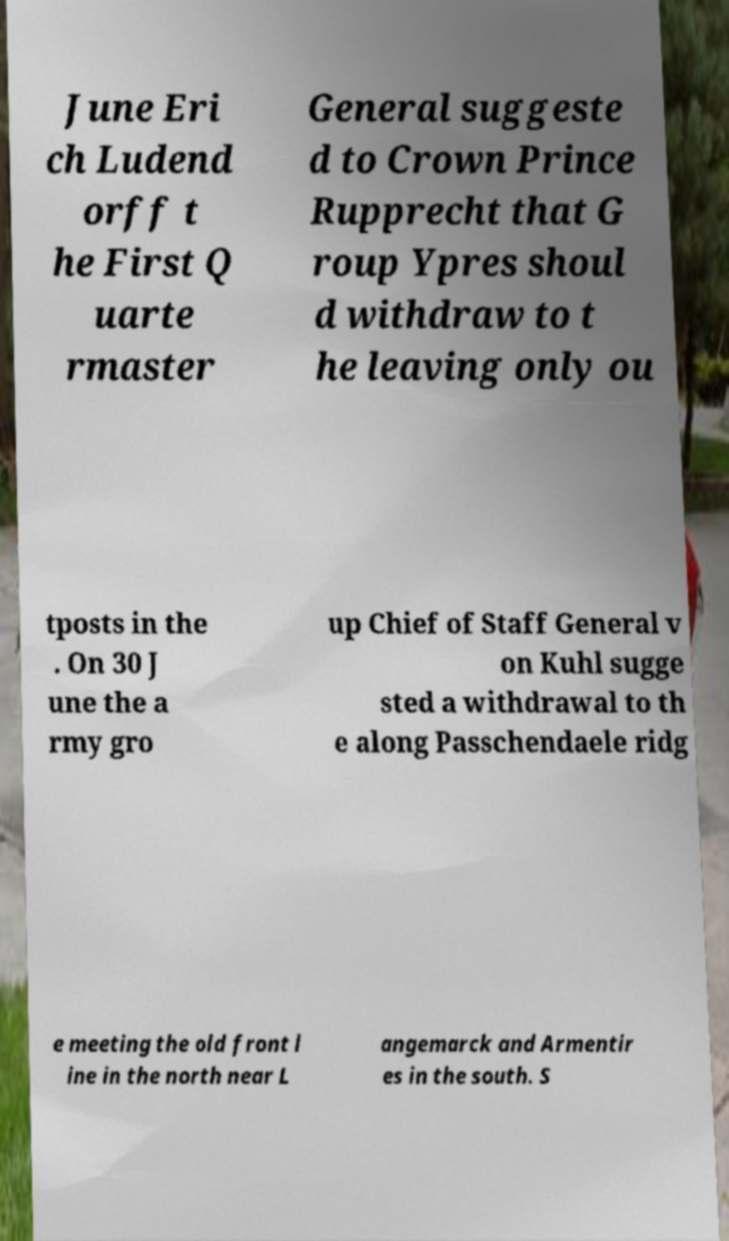Please identify and transcribe the text found in this image. June Eri ch Ludend orff t he First Q uarte rmaster General suggeste d to Crown Prince Rupprecht that G roup Ypres shoul d withdraw to t he leaving only ou tposts in the . On 30 J une the a rmy gro up Chief of Staff General v on Kuhl sugge sted a withdrawal to th e along Passchendaele ridg e meeting the old front l ine in the north near L angemarck and Armentir es in the south. S 